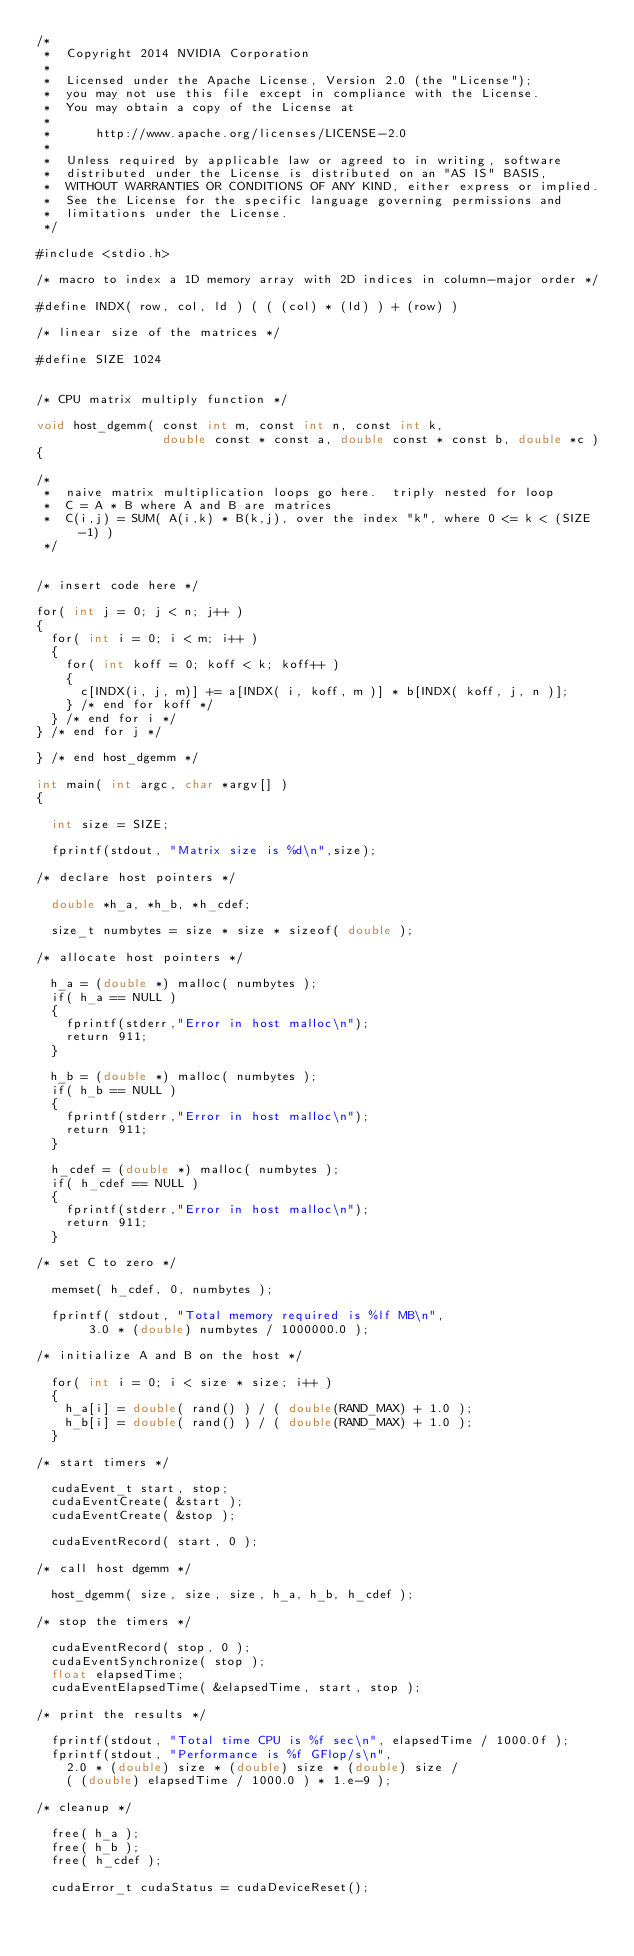<code> <loc_0><loc_0><loc_500><loc_500><_Cuda_>/*
 *  Copyright 2014 NVIDIA Corporation
 *
 *  Licensed under the Apache License, Version 2.0 (the "License");
 *  you may not use this file except in compliance with the License.
 *  You may obtain a copy of the License at
 *
 *      http://www.apache.org/licenses/LICENSE-2.0
 *
 *  Unless required by applicable law or agreed to in writing, software
 *  distributed under the License is distributed on an "AS IS" BASIS,
 *  WITHOUT WARRANTIES OR CONDITIONS OF ANY KIND, either express or implied.
 *  See the License for the specific language governing permissions and
 *  limitations under the License.
 */

#include <stdio.h>

/* macro to index a 1D memory array with 2D indices in column-major order */

#define INDX( row, col, ld ) ( ( (col) * (ld) ) + (row) )

/* linear size of the matrices */

#define SIZE 1024


/* CPU matrix multiply function */

void host_dgemm( const int m, const int n, const int k, 
                 double const * const a, double const * const b, double *c )
{
	
/* 
 *  naive matrix multiplication loops go here.  triply nested for loop
 *  C = A * B where A and B are matrices
 *  C(i,j) = SUM( A(i,k) * B(k,j), over the index "k", where 0 <= k < (SIZE-1) )   
 */     
        

/* insert code here */

for( int j = 0; j < n; j++ )
{
  for( int i = 0; i < m; i++ )
  {
    for( int koff = 0; koff < k; koff++ )
    {
      c[INDX(i, j, m)] += a[INDX( i, koff, m )] * b[INDX( koff, j, n )];
    } /* end for koff */
  } /* end for i */
} /* end for j */

} /* end host_dgemm */

int main( int argc, char *argv[] )
{

  int size = SIZE;

  fprintf(stdout, "Matrix size is %d\n",size);

/* declare host pointers */

  double *h_a, *h_b, *h_cdef;
 
  size_t numbytes = size * size * sizeof( double );

/* allocate host pointers */

  h_a = (double *) malloc( numbytes );
  if( h_a == NULL )
  {
    fprintf(stderr,"Error in host malloc\n");
    return 911;
  }

  h_b = (double *) malloc( numbytes );
  if( h_b == NULL )
  {
    fprintf(stderr,"Error in host malloc\n");
    return 911;
  }

  h_cdef = (double *) malloc( numbytes );
  if( h_cdef == NULL )
  {
    fprintf(stderr,"Error in host malloc\n");
    return 911;
  }

/* set C to zero */

  memset( h_cdef, 0, numbytes );

  fprintf( stdout, "Total memory required is %lf MB\n", 
       3.0 * (double) numbytes / 1000000.0 );

/* initialize A and B on the host */

  for( int i = 0; i < size * size; i++ )
  {
    h_a[i] = double( rand() ) / ( double(RAND_MAX) + 1.0 );
    h_b[i] = double( rand() ) / ( double(RAND_MAX) + 1.0 );
  }

/* start timers */

  cudaEvent_t start, stop;
  cudaEventCreate( &start );
  cudaEventCreate( &stop );

  cudaEventRecord( start, 0 );

/* call host dgemm */

  host_dgemm( size, size, size, h_a, h_b, h_cdef );

/* stop the timers */

  cudaEventRecord( stop, 0 );
  cudaEventSynchronize( stop );
  float elapsedTime;
  cudaEventElapsedTime( &elapsedTime, start, stop );

/* print the results */

  fprintf(stdout, "Total time CPU is %f sec\n", elapsedTime / 1000.0f );
  fprintf(stdout, "Performance is %f GFlop/s\n", 
    2.0 * (double) size * (double) size * (double) size / 
    ( (double) elapsedTime / 1000.0 ) * 1.e-9 );

/* cleanup */

  free( h_a );
  free( h_b );
  free( h_cdef );

  cudaError_t cudaStatus = cudaDeviceReset();</code> 